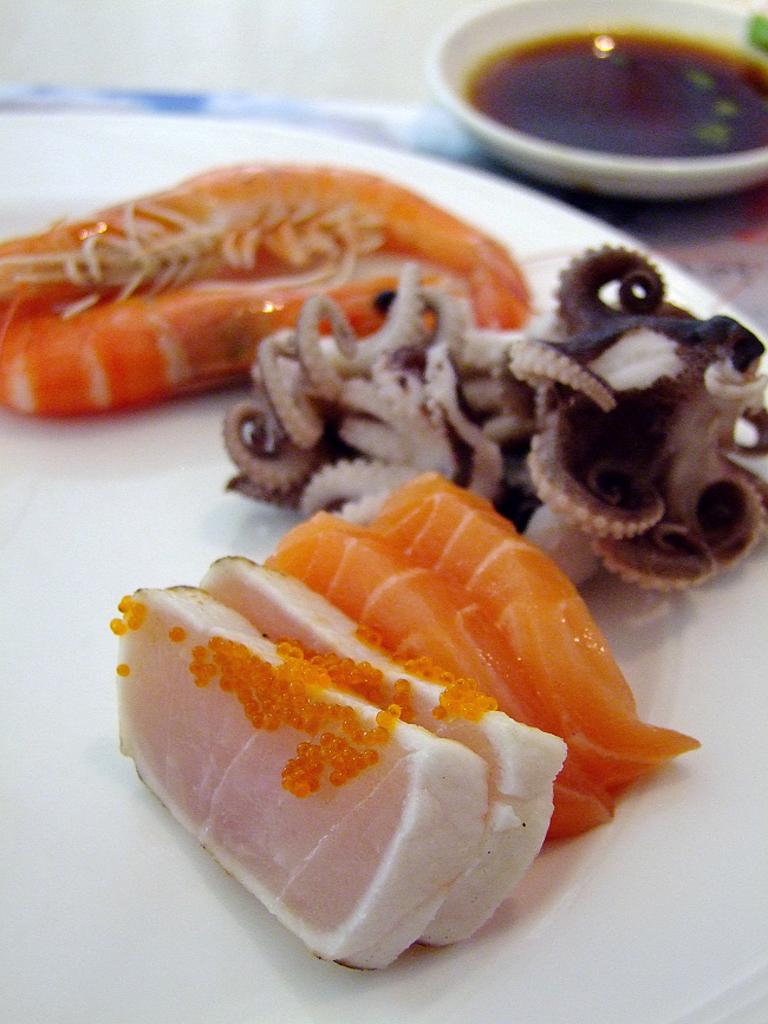What type of food is on the plate in the image? There is raw meat on a plate in the image. What other dish can be seen in the image? There is a dish bowl on the top right side of the image. How many pigs are visible in the image? There are no pigs visible in the image. What type of boats can be seen sailing in the background of the image? There are no boats visible in the image. 